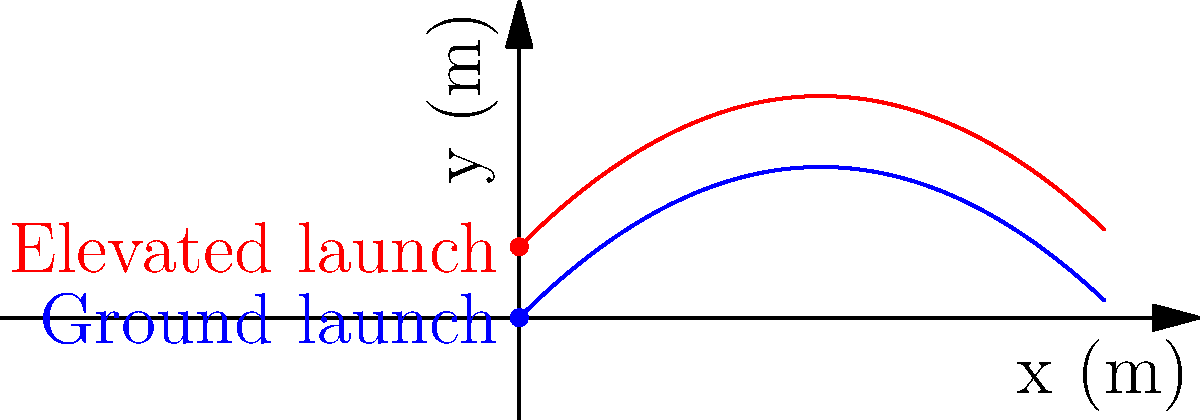As a war correspondent, you're observing artillery fire from two different positions. One launcher is on the ground, and another is on a 30-meter high platform. Both launchers fire projectiles with an initial velocity of 50 m/s at a 45-degree angle. Assuming no air resistance, how much farther will the projectile launched from the elevated position travel compared to the one launched from the ground? Let's approach this step-by-step:

1) The range of a projectile launched from ground level is given by:
   $$R = \frac{v_0^2 \sin(2\theta)}{g}$$

2) For the ground launch:
   $$R_1 = \frac{50^2 \sin(2 \cdot 45°)}{9.8} = \frac{2500 \cdot 1}{9.8} \approx 255.1 \text{ m}$$

3) For the elevated launch, we need to consider the additional time the projectile is in the air due to its initial height. We can find this using the equation:
   $$y = y_0 + v_0\sin(\theta)t - \frac{1}{2}gt^2$$

4) At the landing point, $y = 0$, $y_0 = 30$, so:
   $$0 = 30 + 50\sin(45°)t - \frac{1}{2}(9.8)t^2$$

5) Solving this quadratic equation gives us the total time of flight for the elevated launch. The positive solution is:
   $$t \approx 7.67 \text{ s}$$

6) The horizontal distance traveled is:
   $$R_2 = v_0\cos(\theta)t = 50 \cos(45°) \cdot 7.67 \approx 271.5 \text{ m}$$

7) The difference in range is:
   $$271.5 - 255.1 = 16.4 \text{ m}$$
Answer: 16.4 m 